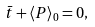Convert formula to latex. <formula><loc_0><loc_0><loc_500><loc_500>\bar { t } + \langle P \rangle _ { 0 } = 0 ,</formula> 